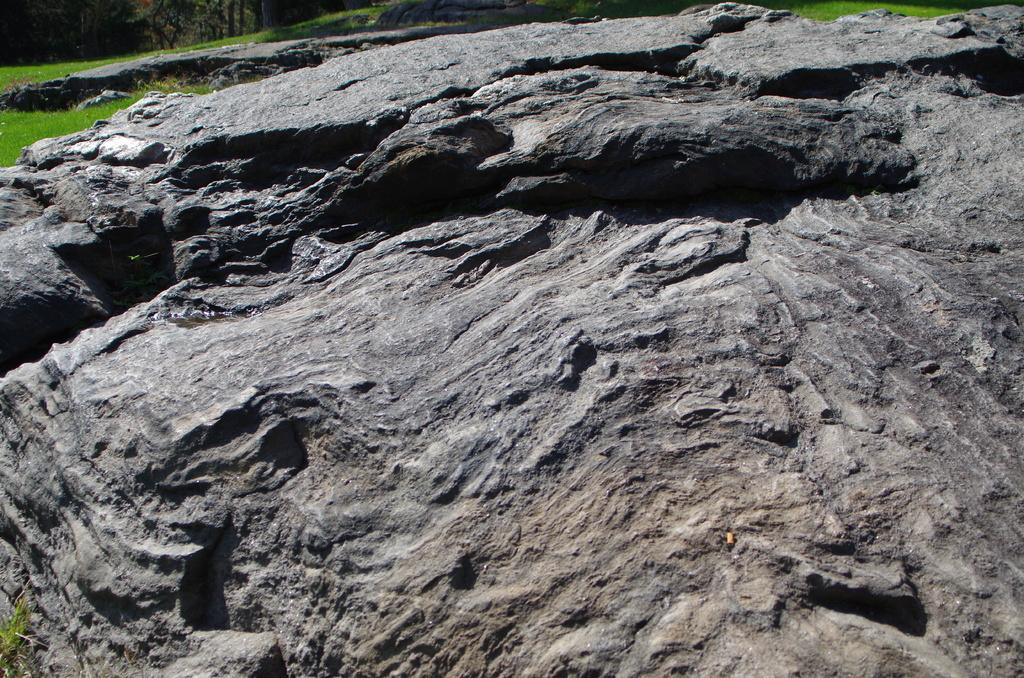What type of natural elements can be seen in the image? There are rocks and grass visible in the image. Are there any plants or vegetation in the image? Yes, there are trees visible at the top of the image. Is there any blood visible on the rocks in the image? No, there is no blood visible on the rocks in the image. What rule is being enforced by the trees in the image? The trees in the image are not enforcing any rules; they are simply part of the natural landscape. 